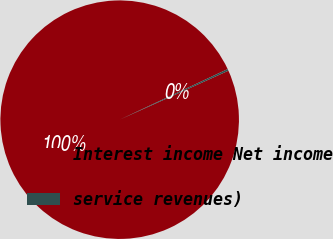Convert chart to OTSL. <chart><loc_0><loc_0><loc_500><loc_500><pie_chart><fcel>Interest income Net income<fcel>service revenues)<nl><fcel>99.76%<fcel>0.24%<nl></chart> 